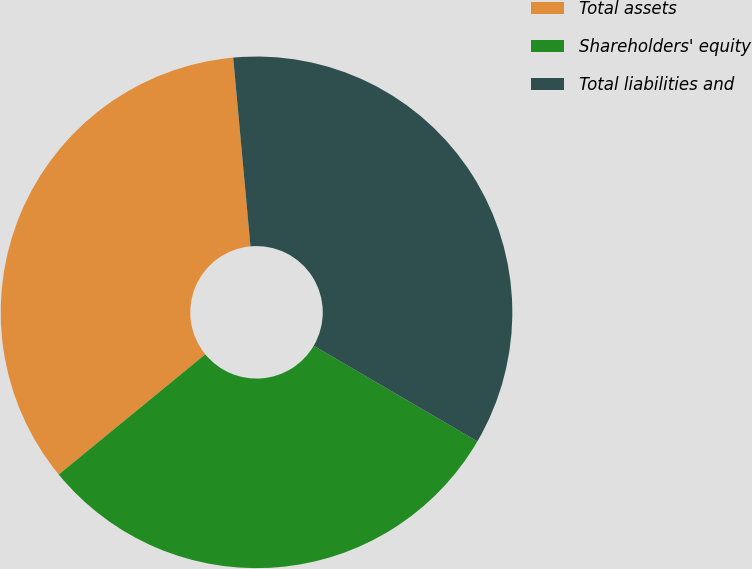Convert chart to OTSL. <chart><loc_0><loc_0><loc_500><loc_500><pie_chart><fcel>Total assets<fcel>Shareholders' equity<fcel>Total liabilities and<nl><fcel>34.48%<fcel>30.65%<fcel>34.87%<nl></chart> 